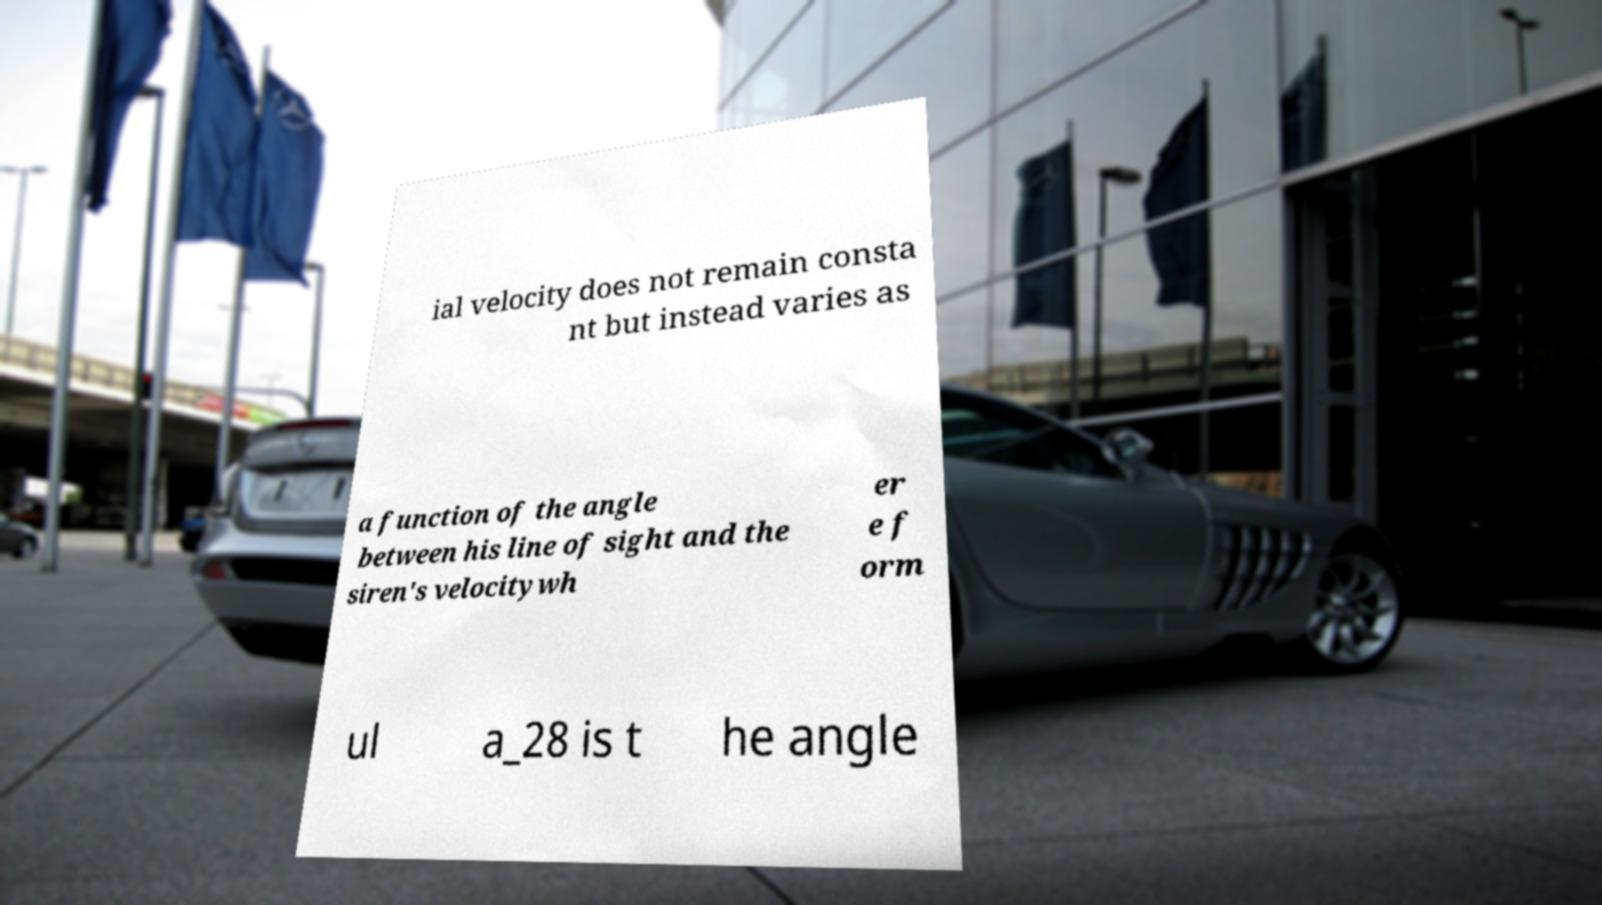Could you extract and type out the text from this image? ial velocity does not remain consta nt but instead varies as a function of the angle between his line of sight and the siren's velocitywh er e f orm ul a_28 is t he angle 